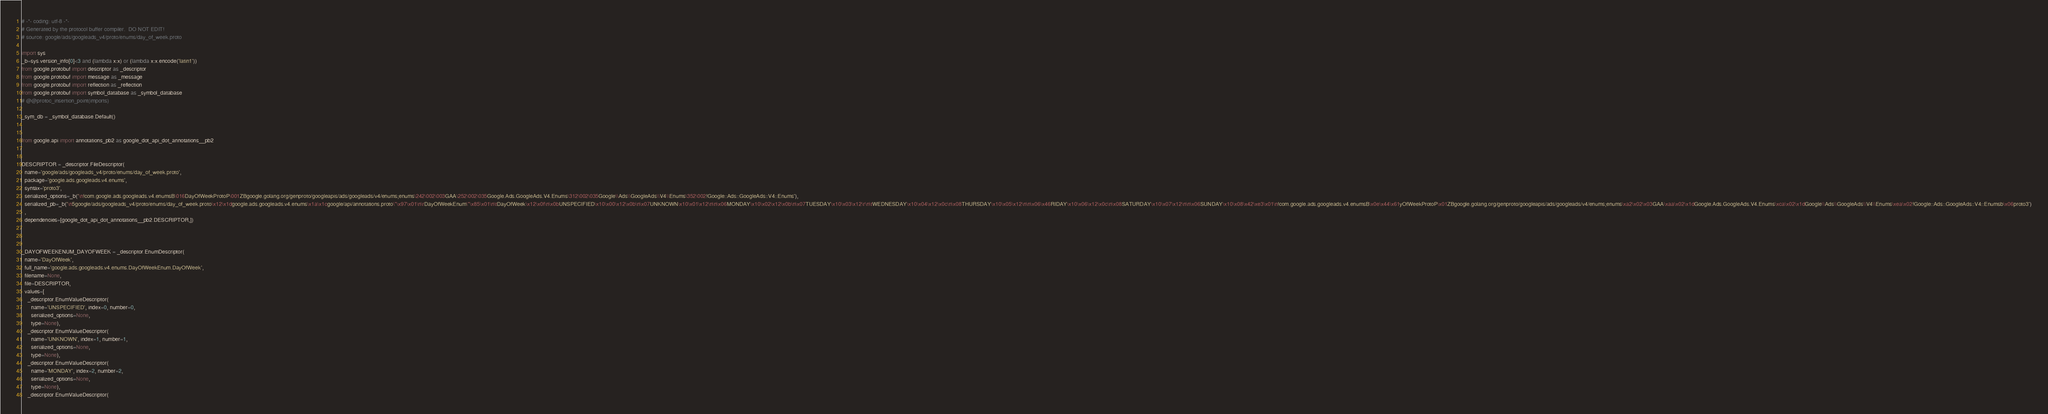<code> <loc_0><loc_0><loc_500><loc_500><_Python_># -*- coding: utf-8 -*-
# Generated by the protocol buffer compiler.  DO NOT EDIT!
# source: google/ads/googleads_v4/proto/enums/day_of_week.proto

import sys
_b=sys.version_info[0]<3 and (lambda x:x) or (lambda x:x.encode('latin1'))
from google.protobuf import descriptor as _descriptor
from google.protobuf import message as _message
from google.protobuf import reflection as _reflection
from google.protobuf import symbol_database as _symbol_database
# @@protoc_insertion_point(imports)

_sym_db = _symbol_database.Default()


from google.api import annotations_pb2 as google_dot_api_dot_annotations__pb2


DESCRIPTOR = _descriptor.FileDescriptor(
  name='google/ads/googleads_v4/proto/enums/day_of_week.proto',
  package='google.ads.googleads.v4.enums',
  syntax='proto3',
  serialized_options=_b('\n!com.google.ads.googleads.v4.enumsB\016DayOfWeekProtoP\001ZBgoogle.golang.org/genproto/googleapis/ads/googleads/v4/enums;enums\242\002\003GAA\252\002\035Google.Ads.GoogleAds.V4.Enums\312\002\035Google\\Ads\\GoogleAds\\V4\\Enums\352\002!Google::Ads::GoogleAds::V4::Enums'),
  serialized_pb=_b('\n5google/ads/googleads_v4/proto/enums/day_of_week.proto\x12\x1dgoogle.ads.googleads.v4.enums\x1a\x1cgoogle/api/annotations.proto\"\x97\x01\n\rDayOfWeekEnum\"\x85\x01\n\tDayOfWeek\x12\x0f\n\x0bUNSPECIFIED\x10\x00\x12\x0b\n\x07UNKNOWN\x10\x01\x12\n\n\x06MONDAY\x10\x02\x12\x0b\n\x07TUESDAY\x10\x03\x12\r\n\tWEDNESDAY\x10\x04\x12\x0c\n\x08THURSDAY\x10\x05\x12\n\n\x06\x46RIDAY\x10\x06\x12\x0c\n\x08SATURDAY\x10\x07\x12\n\n\x06SUNDAY\x10\x08\x42\xe3\x01\n!com.google.ads.googleads.v4.enumsB\x0e\x44\x61yOfWeekProtoP\x01ZBgoogle.golang.org/genproto/googleapis/ads/googleads/v4/enums;enums\xa2\x02\x03GAA\xaa\x02\x1dGoogle.Ads.GoogleAds.V4.Enums\xca\x02\x1dGoogle\\Ads\\GoogleAds\\V4\\Enums\xea\x02!Google::Ads::GoogleAds::V4::Enumsb\x06proto3')
  ,
  dependencies=[google_dot_api_dot_annotations__pb2.DESCRIPTOR,])



_DAYOFWEEKENUM_DAYOFWEEK = _descriptor.EnumDescriptor(
  name='DayOfWeek',
  full_name='google.ads.googleads.v4.enums.DayOfWeekEnum.DayOfWeek',
  filename=None,
  file=DESCRIPTOR,
  values=[
    _descriptor.EnumValueDescriptor(
      name='UNSPECIFIED', index=0, number=0,
      serialized_options=None,
      type=None),
    _descriptor.EnumValueDescriptor(
      name='UNKNOWN', index=1, number=1,
      serialized_options=None,
      type=None),
    _descriptor.EnumValueDescriptor(
      name='MONDAY', index=2, number=2,
      serialized_options=None,
      type=None),
    _descriptor.EnumValueDescriptor(</code> 